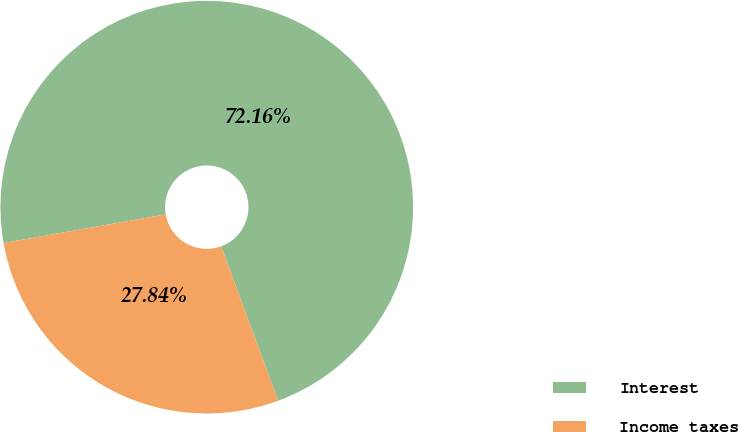<chart> <loc_0><loc_0><loc_500><loc_500><pie_chart><fcel>Interest<fcel>Income taxes<nl><fcel>72.16%<fcel>27.84%<nl></chart> 